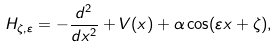Convert formula to latex. <formula><loc_0><loc_0><loc_500><loc_500>H _ { \zeta , \varepsilon } = - \frac { d ^ { 2 } } { d x ^ { 2 } } + V ( x ) + \alpha \cos ( \varepsilon x + \zeta ) ,</formula> 